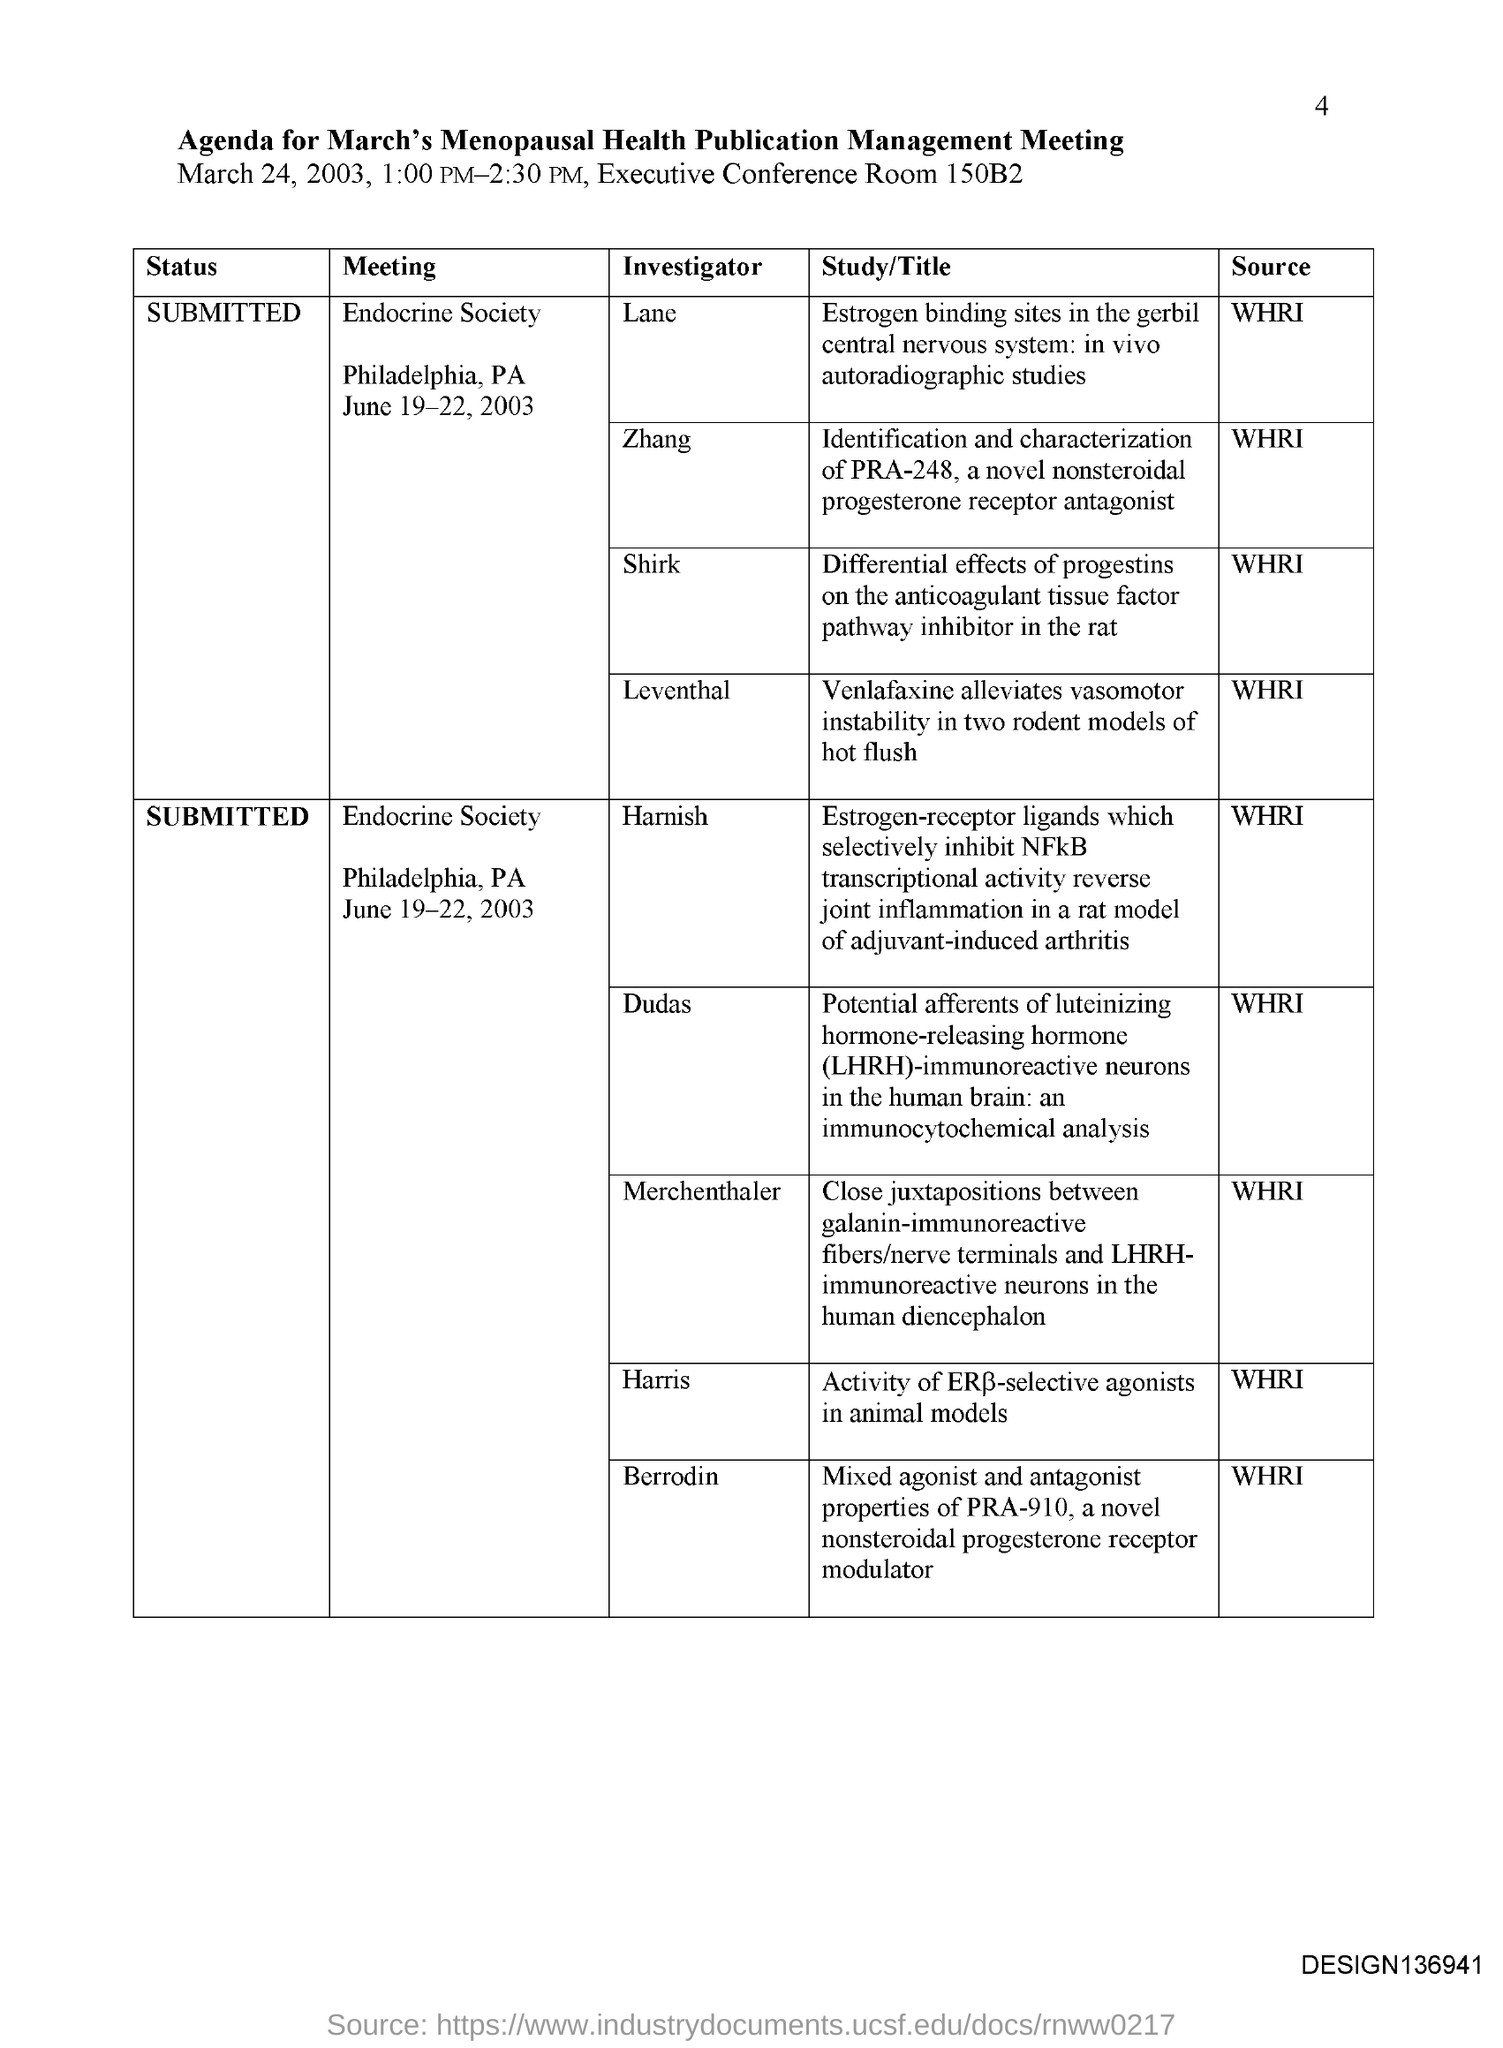What is the agenda for?
Your response must be concise. March's Menopausal Health Publication Management Meeting. What is the date of the meeting?
Give a very brief answer. MARCH 24, 2003. What time is the meeting on March 24, 2003?
Offer a terse response. 1:00 PM-2:30 PM. Where was the meeting held?
Your answer should be compact. Executive conference room 150B2. 